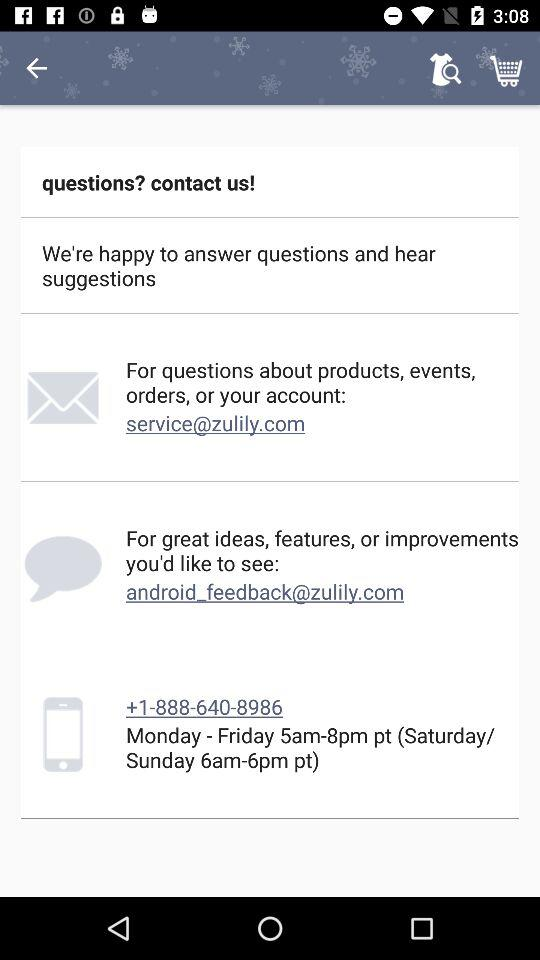What is the contact number? The contact number is +1-888-640-8986. 